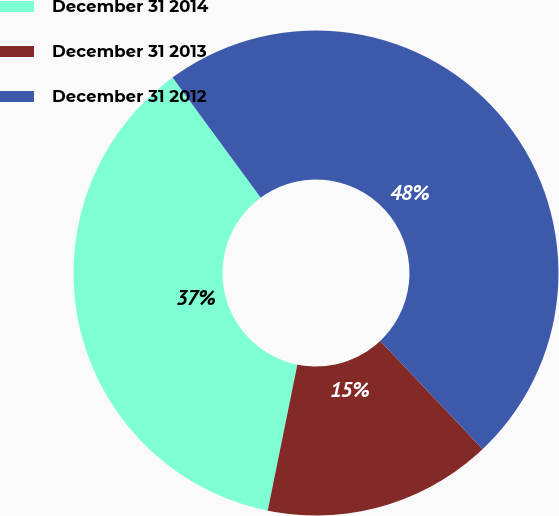Convert chart to OTSL. <chart><loc_0><loc_0><loc_500><loc_500><pie_chart><fcel>December 31 2014<fcel>December 31 2013<fcel>December 31 2012<nl><fcel>36.74%<fcel>15.25%<fcel>48.01%<nl></chart> 